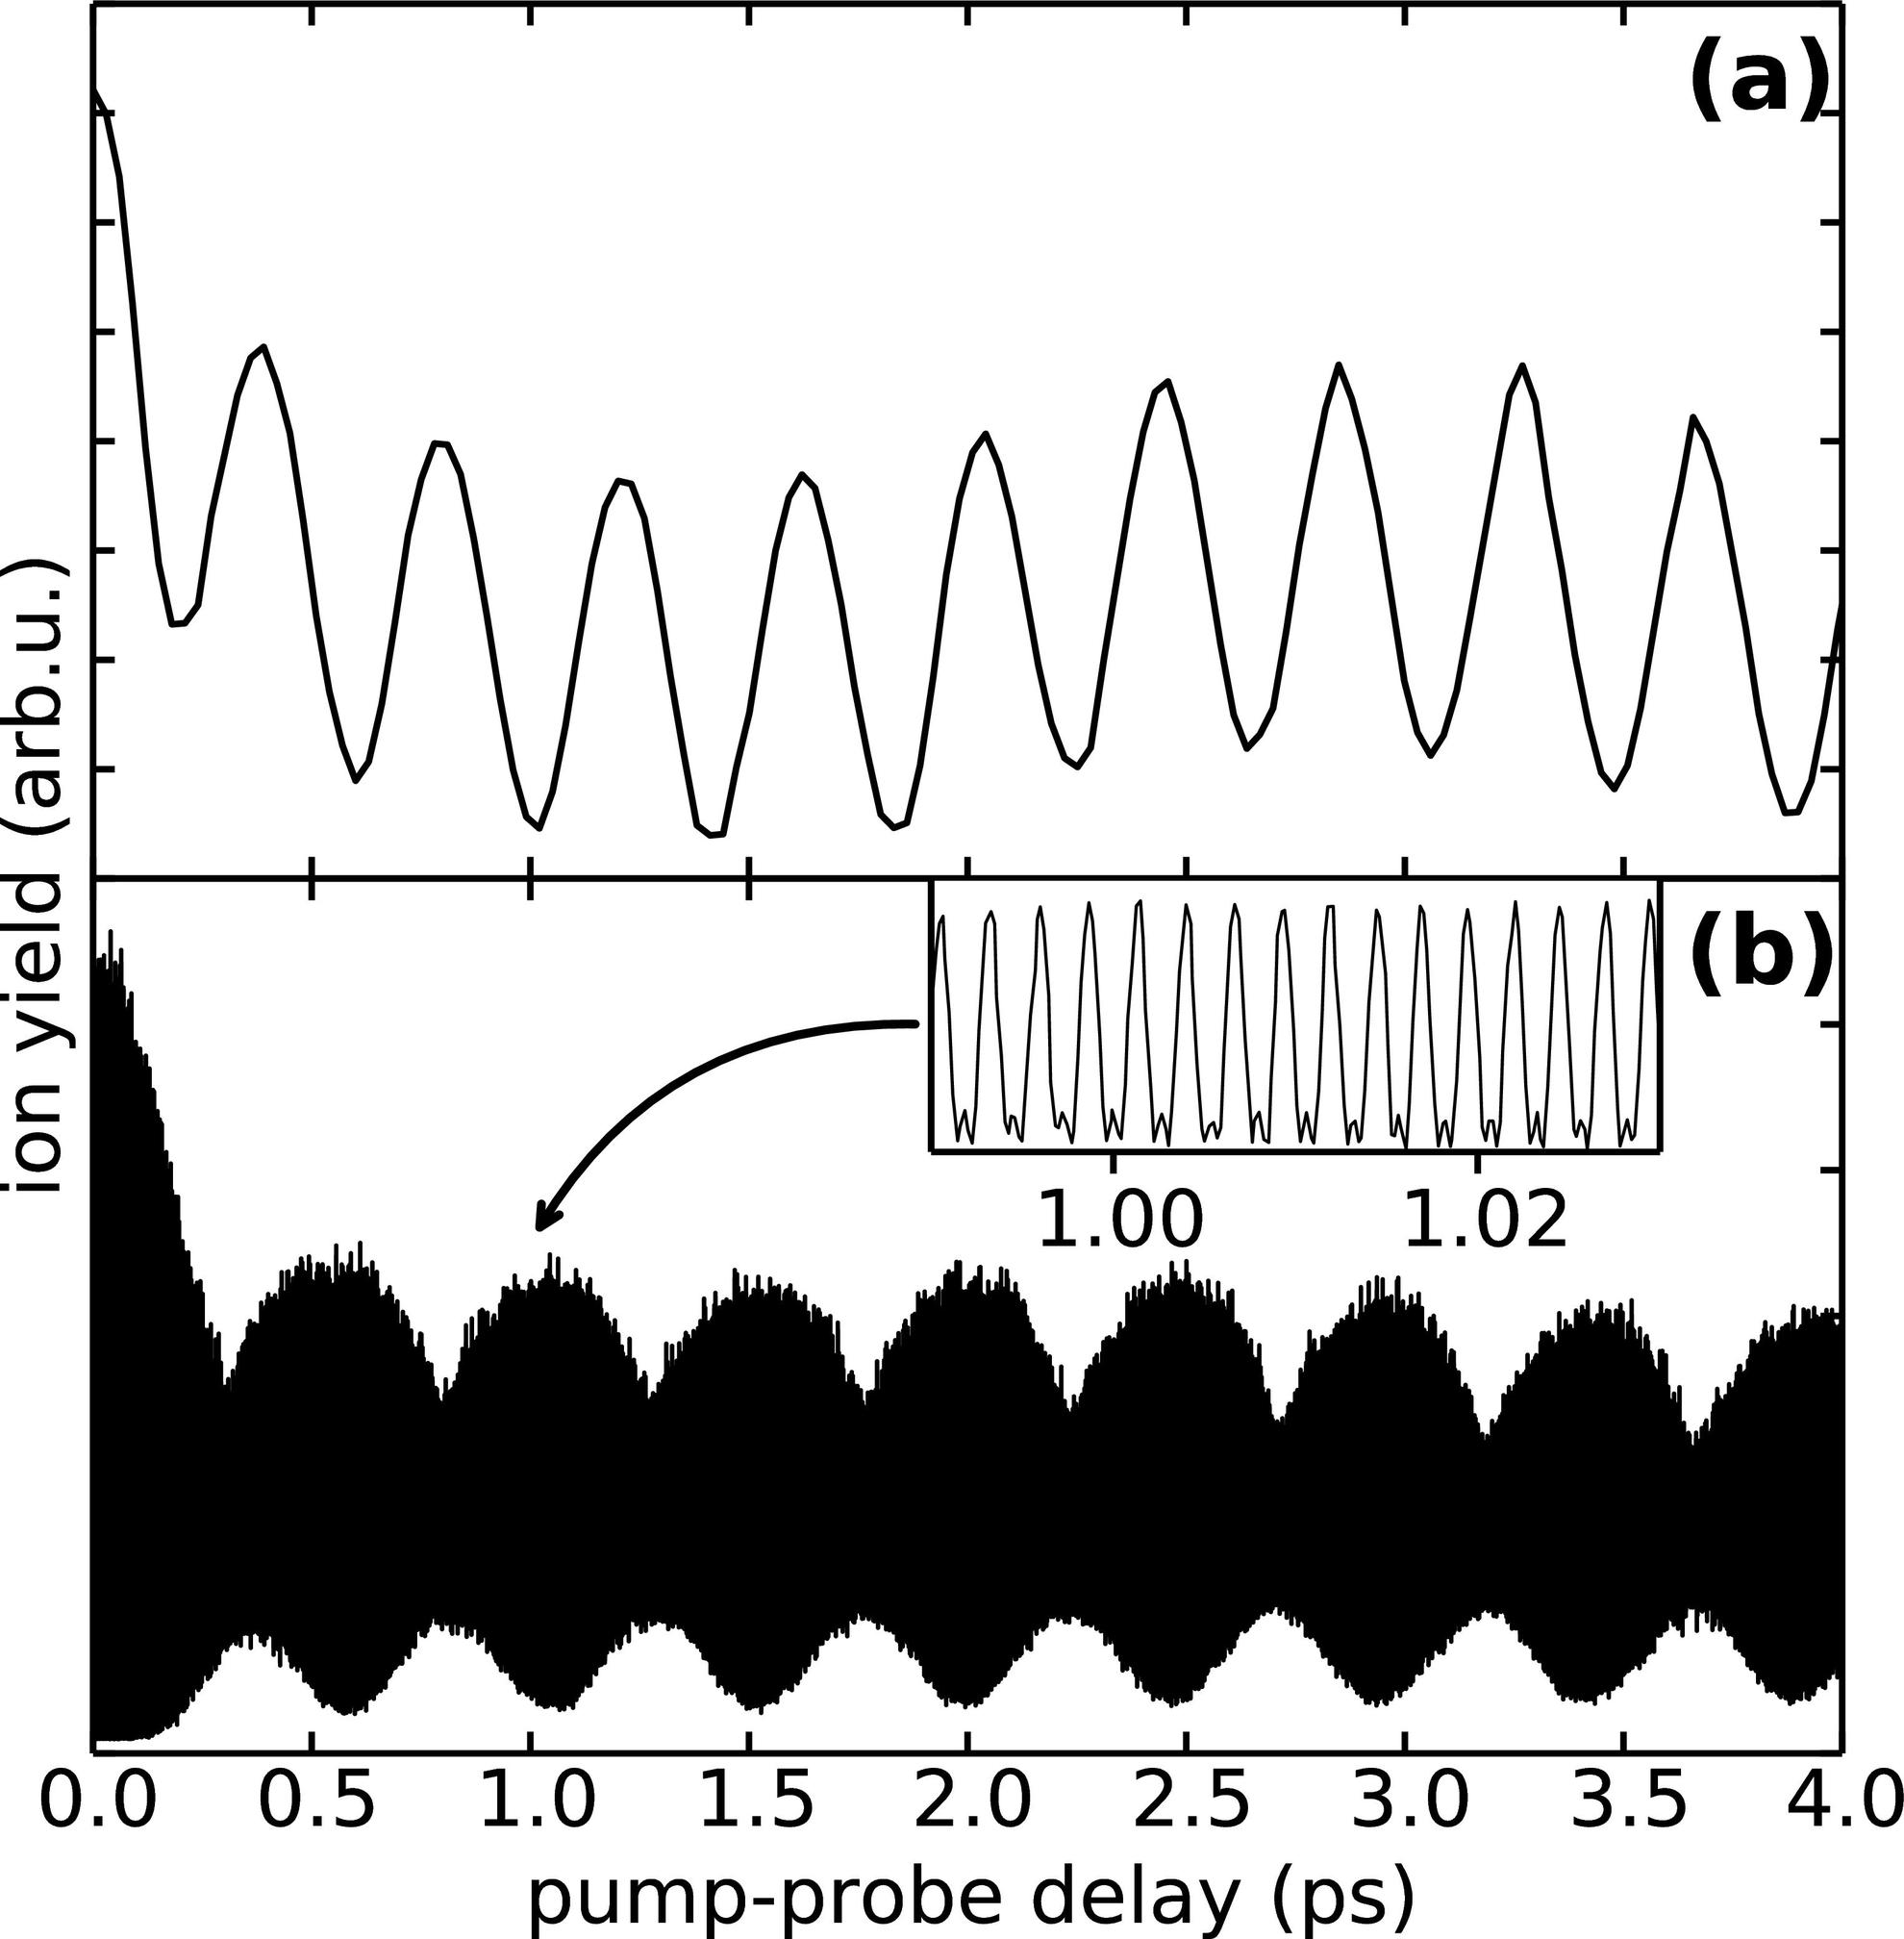What does the inset in panel (b) of the figure highlight? A magnified view of the oscillation pattern around the 1.00 to 1.02 ps region. A different experimental result not related to the main graph. The noise level in the measurement of the ion yield. A comparison between theoretical predictions and experimental data. - The inset in panel (b) provides a magnified view of the graph within the 1.00 to 1.02 ps pump-probe delay region, showing a detailed oscillatory pattern that aligns with the larger oscillations seen in the main graph. The purpose of such insets is typically to provide a closer look at a specific, interesting region of the data. Therefore, the correct answer is A. 